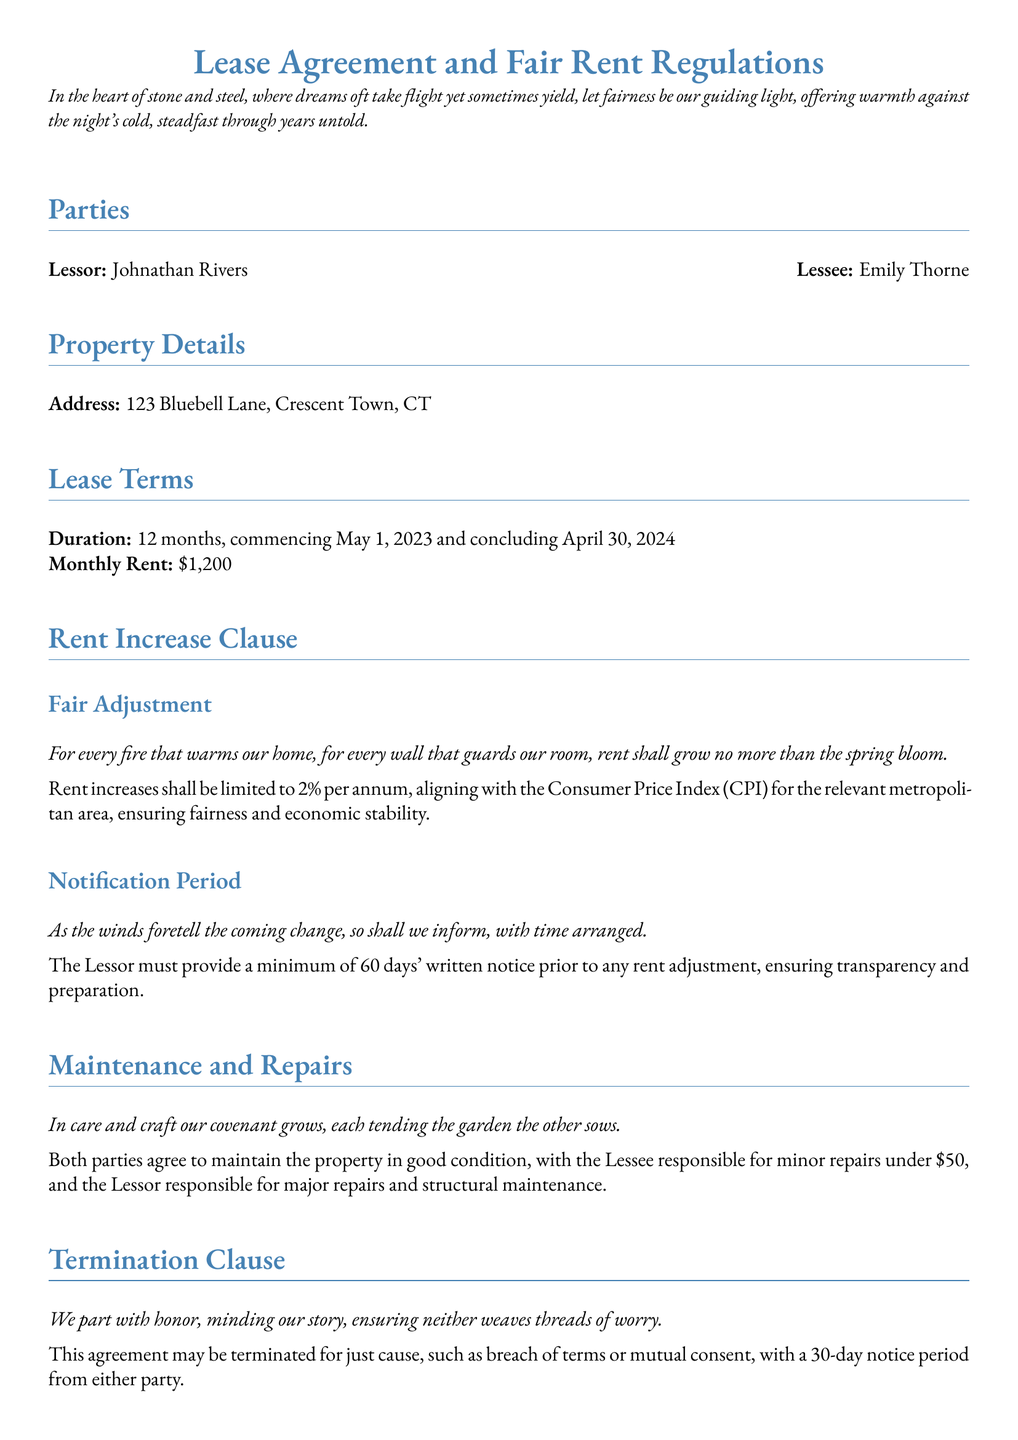what is the name of the lessor? The lessor's name is explicitly stated at the beginning of the document.
Answer: Johnathan Rivers what is the monthly rent? The lease agreement specifies the amount to be paid each month for occupancy of the property.
Answer: $1,200 what is the duration of the lease? The document mentions the starting and concluding date of the lease clearly.
Answer: 12 months what is the maximum rent increase per annum? The rent increase clause outlines the permissible increase in rent as a percentage.
Answer: 2% how many days notice must be given for a rent adjustment? The notification period for informing the lessee about a rent increase is specified.
Answer: 60 days what is the address of the property? The property details section includes the full address where the lease is applicable.
Answer: 123 Bluebell Lane, Crescent Town, CT who is responsible for repairs under $50? The maintenance and repairs section details who takes care of minor issues.
Answer: Lessee how can the lease be terminated? The termination clause outlines the conditions under which the lease can end.
Answer: For just cause what date was the lease agreement signed? The document includes the date when it was officially completed.
Answer: April 25, 2023 